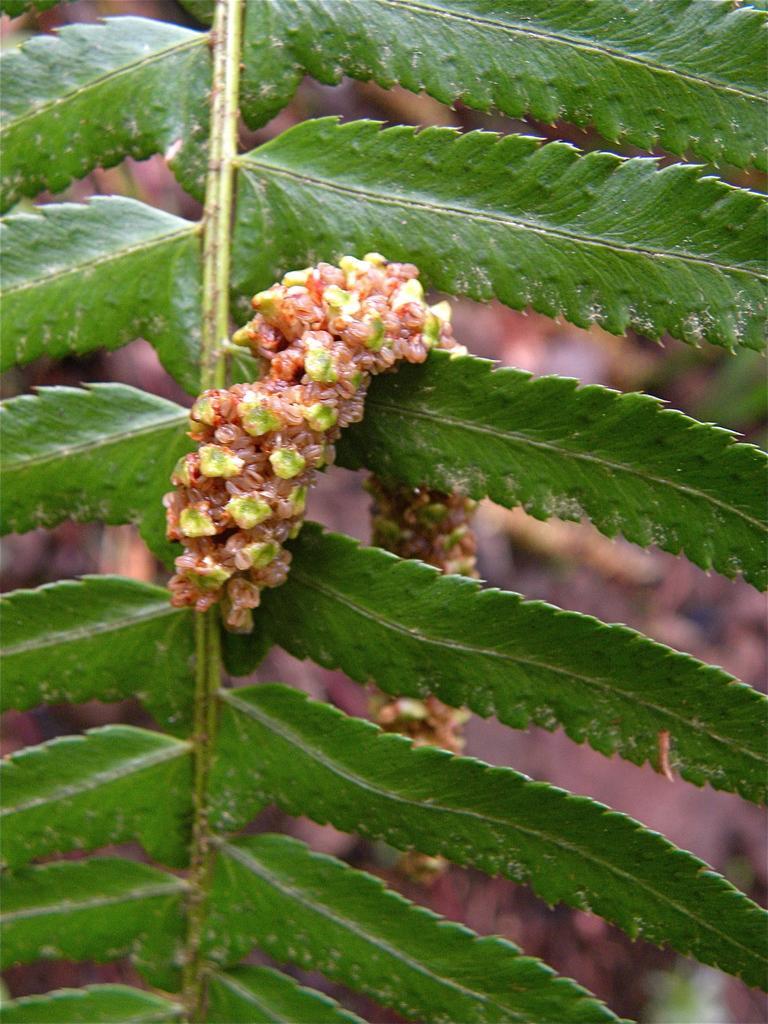How would you summarize this image in a sentence or two? In this image we can see group of leaves on a stem of a plant. 